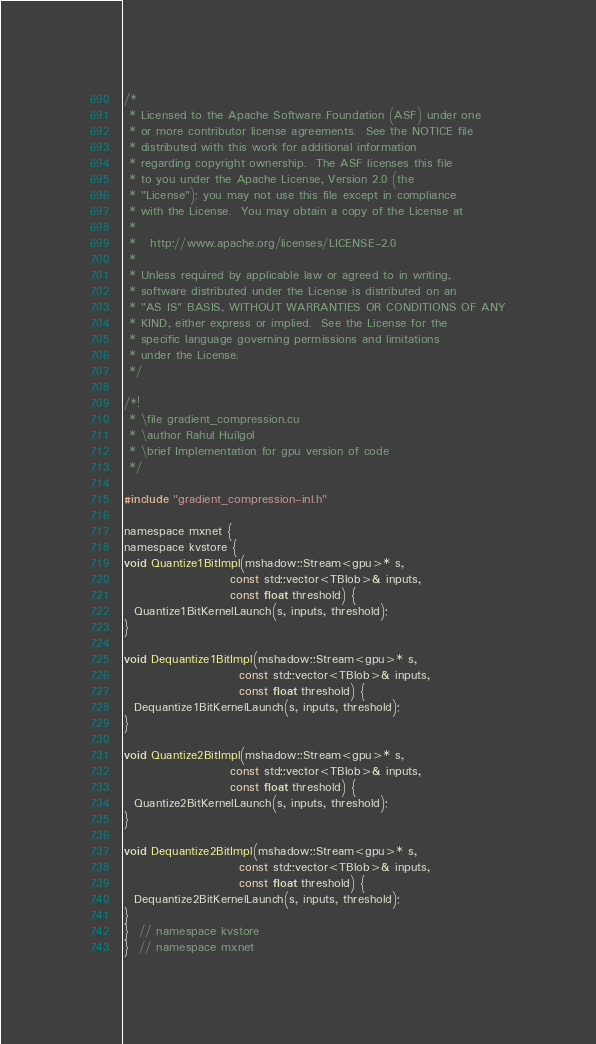<code> <loc_0><loc_0><loc_500><loc_500><_Cuda_>/*
 * Licensed to the Apache Software Foundation (ASF) under one
 * or more contributor license agreements.  See the NOTICE file
 * distributed with this work for additional information
 * regarding copyright ownership.  The ASF licenses this file
 * to you under the Apache License, Version 2.0 (the
 * "License"); you may not use this file except in compliance
 * with the License.  You may obtain a copy of the License at
 *
 *   http://www.apache.org/licenses/LICENSE-2.0
 *
 * Unless required by applicable law or agreed to in writing,
 * software distributed under the License is distributed on an
 * "AS IS" BASIS, WITHOUT WARRANTIES OR CONDITIONS OF ANY
 * KIND, either express or implied.  See the License for the
 * specific language governing permissions and limitations
 * under the License.
 */

/*!
 * \file gradient_compression.cu
 * \author Rahul Huilgol
 * \brief Implementation for gpu version of code
 */

#include "gradient_compression-inl.h"

namespace mxnet {
namespace kvstore {
void Quantize1BitImpl(mshadow::Stream<gpu>* s,
                      const std::vector<TBlob>& inputs,
                      const float threshold) {
  Quantize1BitKernelLaunch(s, inputs, threshold);
}

void Dequantize1BitImpl(mshadow::Stream<gpu>* s,
                        const std::vector<TBlob>& inputs,
                        const float threshold) {
  Dequantize1BitKernelLaunch(s, inputs, threshold);
}

void Quantize2BitImpl(mshadow::Stream<gpu>* s,
                      const std::vector<TBlob>& inputs,
                      const float threshold) {
  Quantize2BitKernelLaunch(s, inputs, threshold);
}

void Dequantize2BitImpl(mshadow::Stream<gpu>* s,
                        const std::vector<TBlob>& inputs,
                        const float threshold) {
  Dequantize2BitKernelLaunch(s, inputs, threshold);
}
}  // namespace kvstore
}  // namespace mxnet
</code> 